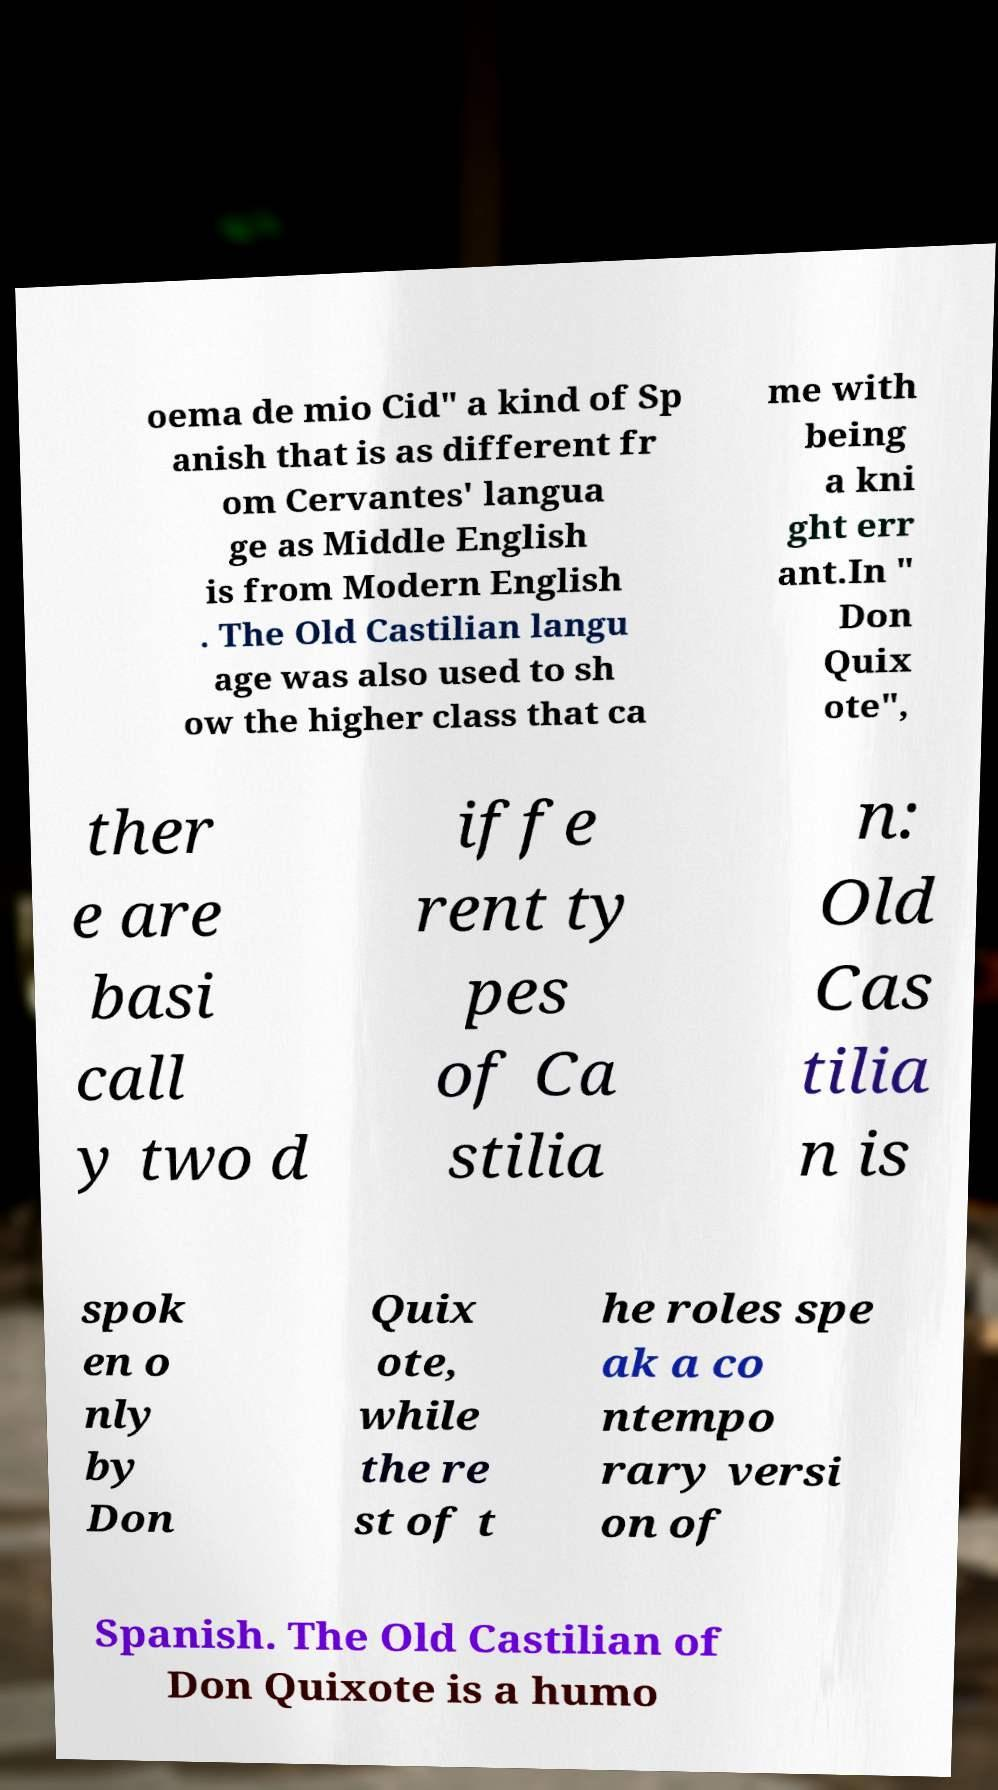Please identify and transcribe the text found in this image. oema de mio Cid" a kind of Sp anish that is as different fr om Cervantes' langua ge as Middle English is from Modern English . The Old Castilian langu age was also used to sh ow the higher class that ca me with being a kni ght err ant.In " Don Quix ote", ther e are basi call y two d iffe rent ty pes of Ca stilia n: Old Cas tilia n is spok en o nly by Don Quix ote, while the re st of t he roles spe ak a co ntempo rary versi on of Spanish. The Old Castilian of Don Quixote is a humo 